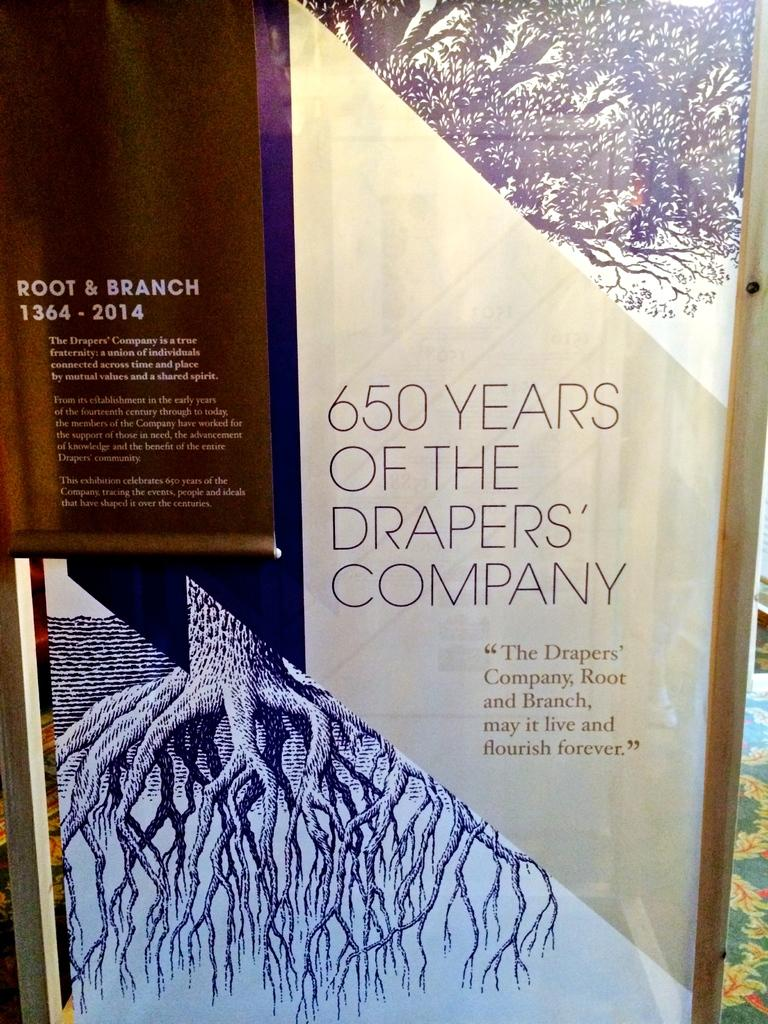Provide a one-sentence caption for the provided image. Sign that says 650 years of the Draper's Company in a room. 